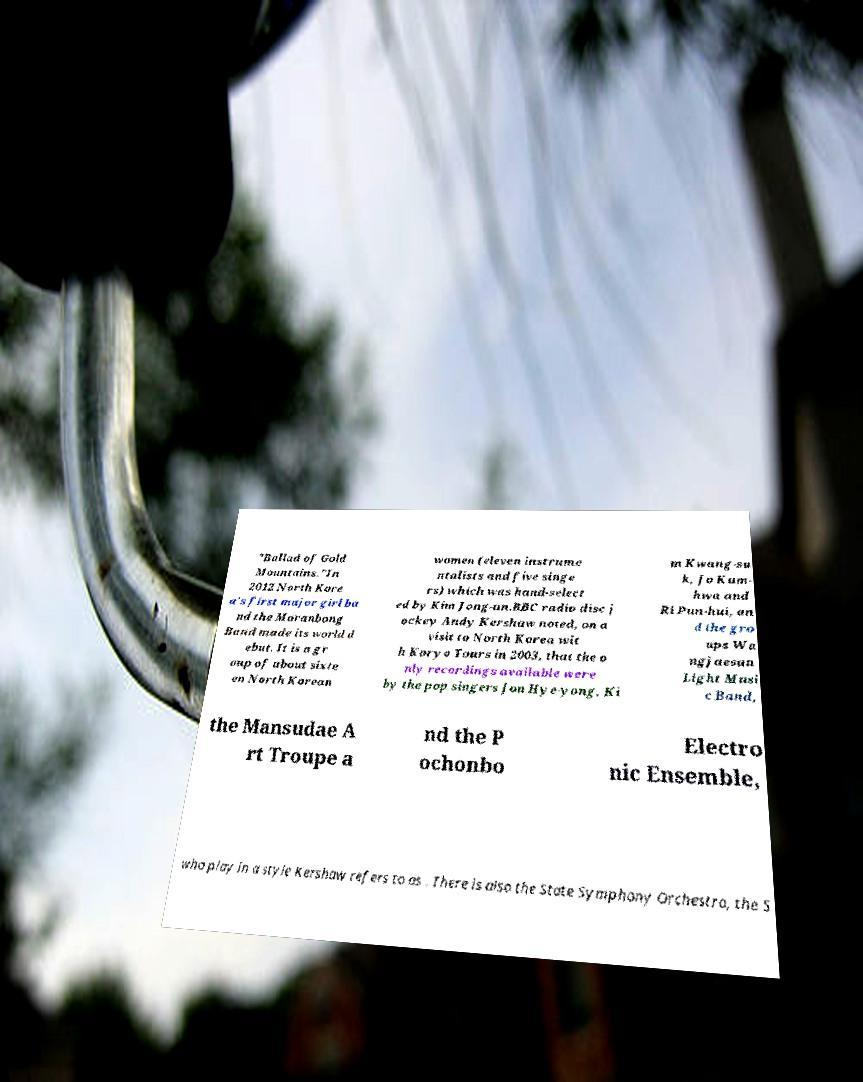Could you extract and type out the text from this image? "Ballad of Gold Mountains."In 2012 North Kore a's first major girl ba nd the Moranbong Band made its world d ebut. It is a gr oup of about sixte en North Korean women (eleven instrume ntalists and five singe rs) which was hand-select ed by Kim Jong-un.BBC radio disc j ockey Andy Kershaw noted, on a visit to North Korea wit h Koryo Tours in 2003, that the o nly recordings available were by the pop singers Jon Hye-yong, Ki m Kwang-su k, Jo Kum- hwa and Ri Pun-hui, an d the gro ups Wa ngjaesan Light Musi c Band, the Mansudae A rt Troupe a nd the P ochonbo Electro nic Ensemble, who play in a style Kershaw refers to as . There is also the State Symphony Orchestra, the S 